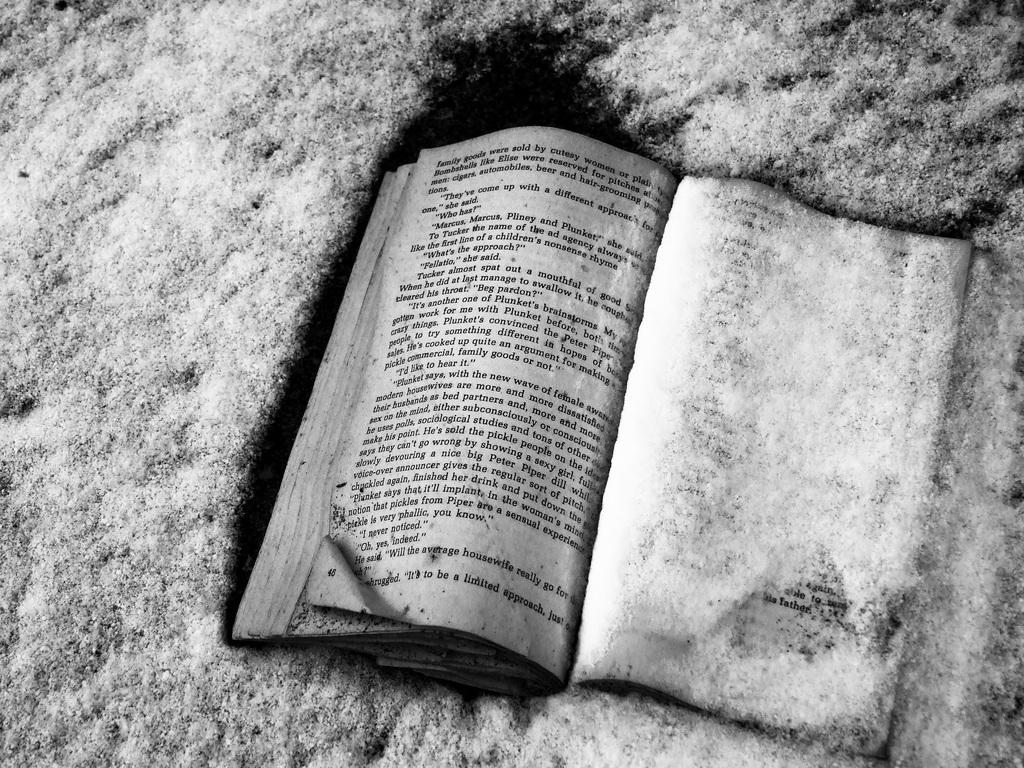What is the color scheme of the image? The image is black and white. What can be seen in the image? There is an open book in the image. Can you describe the background of the image? The background of the image is not clear. What type of joke is being told in the image? There is no joke present in the image; it features an open book. Is there any evidence of war in the image? There is no evidence of war present in the image; it features an open book. What type of love is being expressed in the image? There is no love being expressed in the image; it features an open book. 